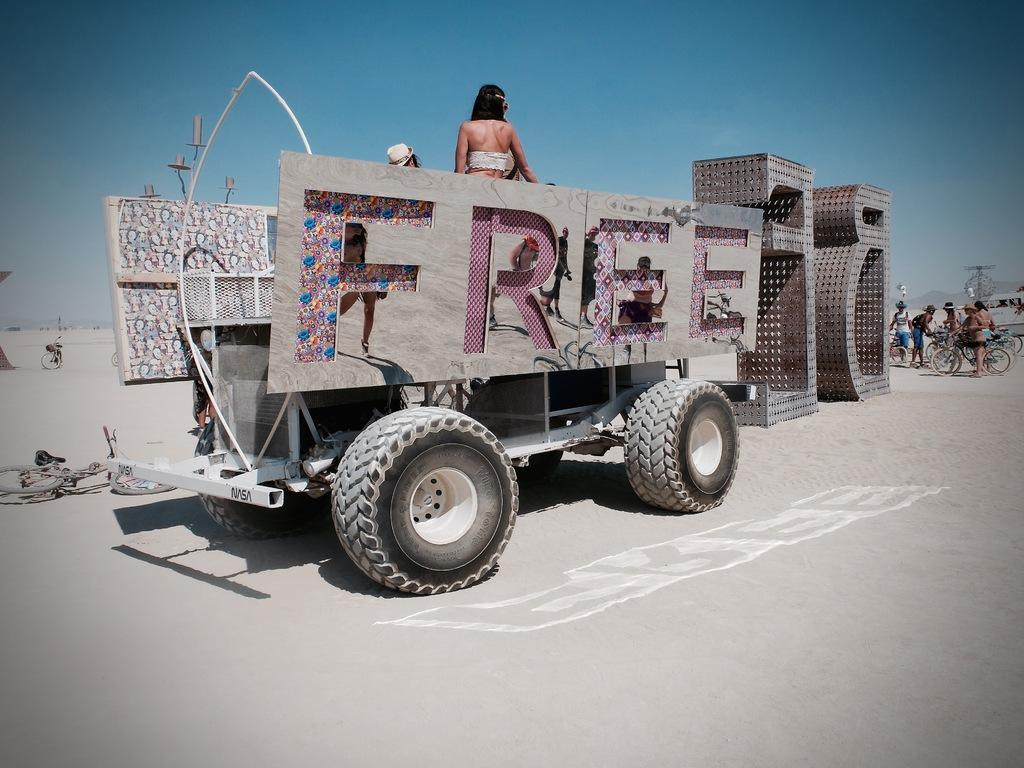What is the main subject of the image? There is a vehicle on the road in the image. Can you describe any other elements in the image? Yes, there are people visible in the image. What can be seen in the background of the image? The sky is visible at the top of the image. What type of feather can be seen falling from the sky in the image? There is no feather visible in the image; only the vehicle, people, and sky are present. 